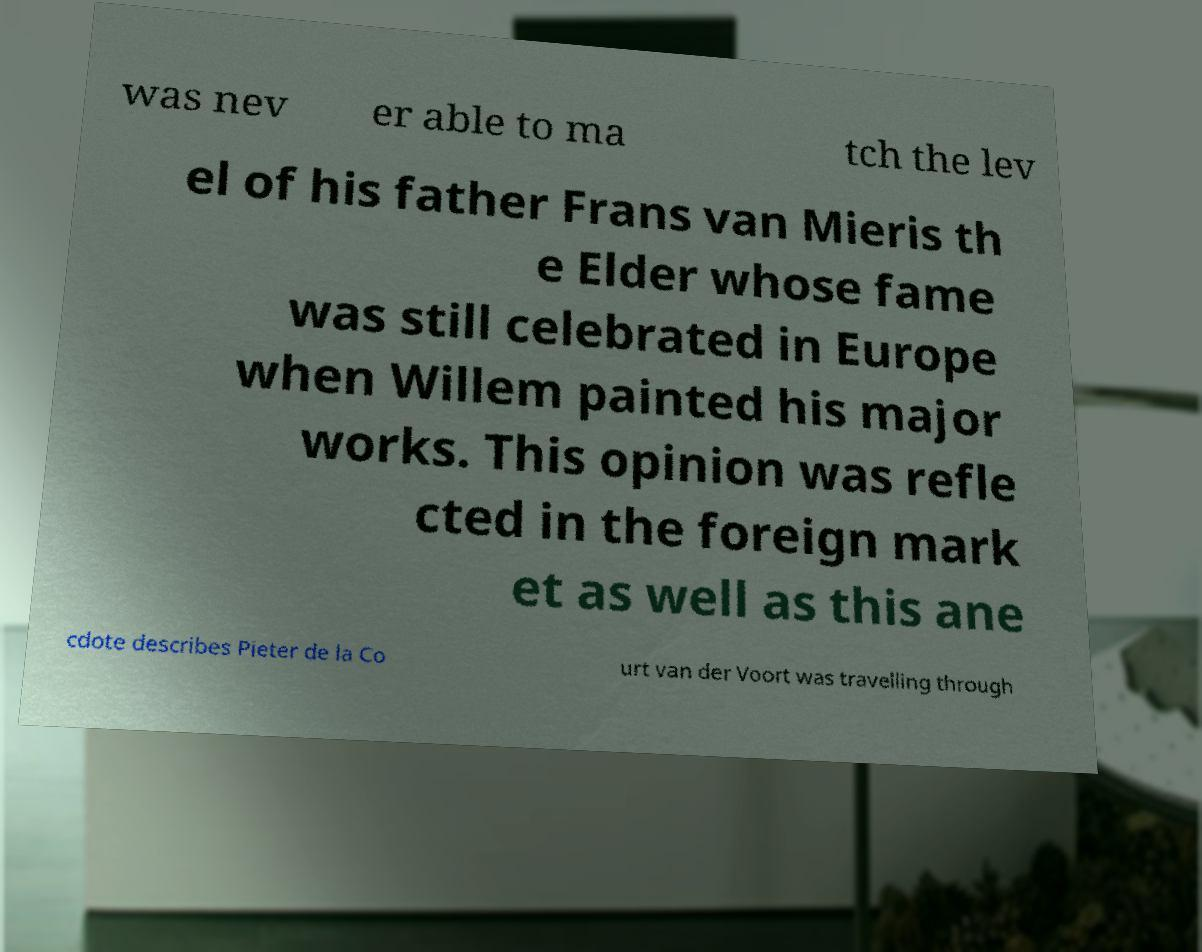There's text embedded in this image that I need extracted. Can you transcribe it verbatim? was nev er able to ma tch the lev el of his father Frans van Mieris th e Elder whose fame was still celebrated in Europe when Willem painted his major works. This opinion was refle cted in the foreign mark et as well as this ane cdote describes Pieter de la Co urt van der Voort was travelling through 